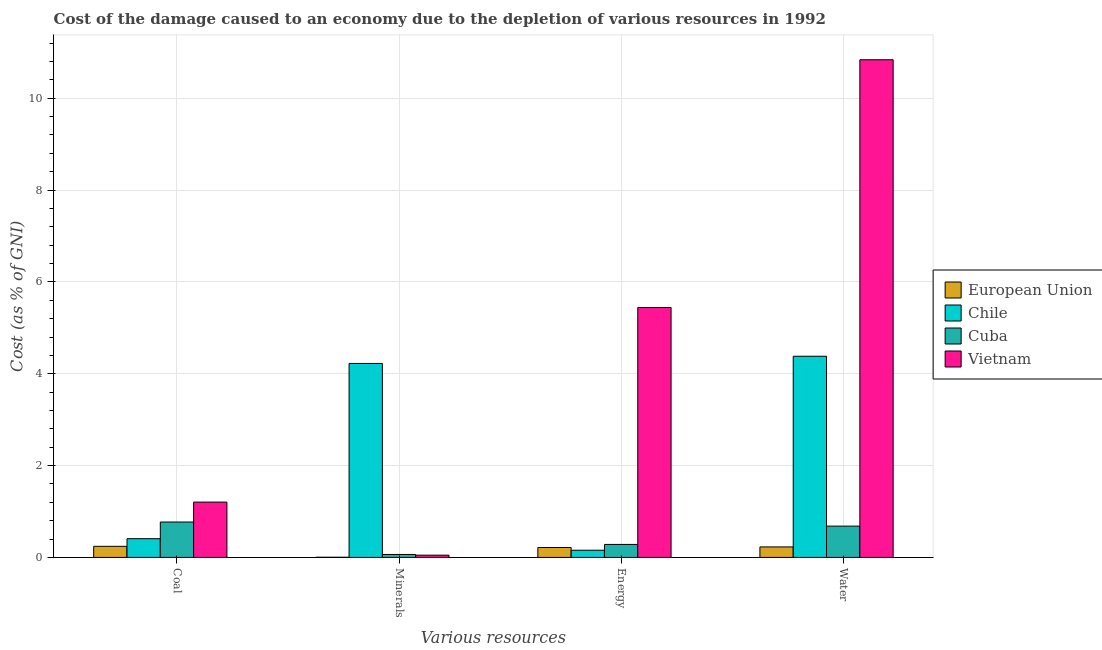How many groups of bars are there?
Provide a short and direct response. 4. Are the number of bars per tick equal to the number of legend labels?
Your answer should be very brief. Yes. Are the number of bars on each tick of the X-axis equal?
Keep it short and to the point. Yes. What is the label of the 1st group of bars from the left?
Give a very brief answer. Coal. What is the cost of damage due to depletion of water in Cuba?
Your answer should be very brief. 0.68. Across all countries, what is the maximum cost of damage due to depletion of coal?
Keep it short and to the point. 1.2. Across all countries, what is the minimum cost of damage due to depletion of minerals?
Your response must be concise. 0. In which country was the cost of damage due to depletion of energy maximum?
Provide a succinct answer. Vietnam. In which country was the cost of damage due to depletion of minerals minimum?
Provide a succinct answer. European Union. What is the total cost of damage due to depletion of water in the graph?
Provide a succinct answer. 16.13. What is the difference between the cost of damage due to depletion of minerals in European Union and that in Vietnam?
Offer a terse response. -0.05. What is the difference between the cost of damage due to depletion of energy in Cuba and the cost of damage due to depletion of coal in European Union?
Give a very brief answer. 0.04. What is the average cost of damage due to depletion of minerals per country?
Your answer should be very brief. 1.09. What is the difference between the cost of damage due to depletion of minerals and cost of damage due to depletion of coal in Chile?
Offer a very short reply. 3.82. What is the ratio of the cost of damage due to depletion of coal in Cuba to that in Vietnam?
Keep it short and to the point. 0.64. Is the difference between the cost of damage due to depletion of coal in Vietnam and European Union greater than the difference between the cost of damage due to depletion of energy in Vietnam and European Union?
Provide a succinct answer. No. What is the difference between the highest and the second highest cost of damage due to depletion of energy?
Your answer should be compact. 5.16. What is the difference between the highest and the lowest cost of damage due to depletion of coal?
Your answer should be compact. 0.96. Is the sum of the cost of damage due to depletion of energy in Cuba and European Union greater than the maximum cost of damage due to depletion of coal across all countries?
Your answer should be very brief. No. Is it the case that in every country, the sum of the cost of damage due to depletion of energy and cost of damage due to depletion of coal is greater than the sum of cost of damage due to depletion of minerals and cost of damage due to depletion of water?
Your answer should be very brief. No. What does the 2nd bar from the right in Coal represents?
Provide a succinct answer. Cuba. How many bars are there?
Offer a terse response. 16. Are all the bars in the graph horizontal?
Ensure brevity in your answer.  No. How many countries are there in the graph?
Offer a very short reply. 4. Where does the legend appear in the graph?
Make the answer very short. Center right. What is the title of the graph?
Provide a succinct answer. Cost of the damage caused to an economy due to the depletion of various resources in 1992 . Does "Bulgaria" appear as one of the legend labels in the graph?
Your response must be concise. No. What is the label or title of the X-axis?
Provide a short and direct response. Various resources. What is the label or title of the Y-axis?
Provide a short and direct response. Cost (as % of GNI). What is the Cost (as % of GNI) of European Union in Coal?
Provide a short and direct response. 0.24. What is the Cost (as % of GNI) of Chile in Coal?
Provide a succinct answer. 0.41. What is the Cost (as % of GNI) of Cuba in Coal?
Your response must be concise. 0.77. What is the Cost (as % of GNI) in Vietnam in Coal?
Provide a short and direct response. 1.2. What is the Cost (as % of GNI) in European Union in Minerals?
Provide a short and direct response. 0. What is the Cost (as % of GNI) in Chile in Minerals?
Your response must be concise. 4.22. What is the Cost (as % of GNI) in Cuba in Minerals?
Ensure brevity in your answer.  0.06. What is the Cost (as % of GNI) of Vietnam in Minerals?
Your response must be concise. 0.05. What is the Cost (as % of GNI) of European Union in Energy?
Make the answer very short. 0.22. What is the Cost (as % of GNI) in Chile in Energy?
Your answer should be compact. 0.16. What is the Cost (as % of GNI) in Cuba in Energy?
Give a very brief answer. 0.28. What is the Cost (as % of GNI) of Vietnam in Energy?
Offer a terse response. 5.44. What is the Cost (as % of GNI) of European Union in Water?
Make the answer very short. 0.23. What is the Cost (as % of GNI) of Chile in Water?
Provide a succinct answer. 4.38. What is the Cost (as % of GNI) in Cuba in Water?
Provide a short and direct response. 0.68. What is the Cost (as % of GNI) of Vietnam in Water?
Offer a terse response. 10.84. Across all Various resources, what is the maximum Cost (as % of GNI) in European Union?
Give a very brief answer. 0.24. Across all Various resources, what is the maximum Cost (as % of GNI) of Chile?
Your answer should be compact. 4.38. Across all Various resources, what is the maximum Cost (as % of GNI) in Cuba?
Your response must be concise. 0.77. Across all Various resources, what is the maximum Cost (as % of GNI) of Vietnam?
Give a very brief answer. 10.84. Across all Various resources, what is the minimum Cost (as % of GNI) of European Union?
Ensure brevity in your answer.  0. Across all Various resources, what is the minimum Cost (as % of GNI) of Chile?
Give a very brief answer. 0.16. Across all Various resources, what is the minimum Cost (as % of GNI) in Cuba?
Make the answer very short. 0.06. Across all Various resources, what is the minimum Cost (as % of GNI) of Vietnam?
Make the answer very short. 0.05. What is the total Cost (as % of GNI) of European Union in the graph?
Provide a short and direct response. 0.69. What is the total Cost (as % of GNI) of Chile in the graph?
Your answer should be compact. 9.17. What is the total Cost (as % of GNI) in Cuba in the graph?
Offer a very short reply. 1.8. What is the total Cost (as % of GNI) of Vietnam in the graph?
Your answer should be compact. 17.53. What is the difference between the Cost (as % of GNI) in European Union in Coal and that in Minerals?
Make the answer very short. 0.24. What is the difference between the Cost (as % of GNI) of Chile in Coal and that in Minerals?
Ensure brevity in your answer.  -3.82. What is the difference between the Cost (as % of GNI) in Cuba in Coal and that in Minerals?
Your answer should be very brief. 0.71. What is the difference between the Cost (as % of GNI) of Vietnam in Coal and that in Minerals?
Make the answer very short. 1.16. What is the difference between the Cost (as % of GNI) in European Union in Coal and that in Energy?
Your answer should be very brief. 0.03. What is the difference between the Cost (as % of GNI) in Chile in Coal and that in Energy?
Ensure brevity in your answer.  0.25. What is the difference between the Cost (as % of GNI) in Cuba in Coal and that in Energy?
Ensure brevity in your answer.  0.49. What is the difference between the Cost (as % of GNI) of Vietnam in Coal and that in Energy?
Your answer should be compact. -4.24. What is the difference between the Cost (as % of GNI) in European Union in Coal and that in Water?
Offer a terse response. 0.01. What is the difference between the Cost (as % of GNI) of Chile in Coal and that in Water?
Your answer should be very brief. -3.97. What is the difference between the Cost (as % of GNI) of Cuba in Coal and that in Water?
Offer a very short reply. 0.09. What is the difference between the Cost (as % of GNI) of Vietnam in Coal and that in Water?
Your answer should be very brief. -9.63. What is the difference between the Cost (as % of GNI) of European Union in Minerals and that in Energy?
Ensure brevity in your answer.  -0.21. What is the difference between the Cost (as % of GNI) in Chile in Minerals and that in Energy?
Keep it short and to the point. 4.07. What is the difference between the Cost (as % of GNI) of Cuba in Minerals and that in Energy?
Your response must be concise. -0.22. What is the difference between the Cost (as % of GNI) in Vietnam in Minerals and that in Energy?
Make the answer very short. -5.39. What is the difference between the Cost (as % of GNI) in European Union in Minerals and that in Water?
Your response must be concise. -0.23. What is the difference between the Cost (as % of GNI) in Chile in Minerals and that in Water?
Keep it short and to the point. -0.16. What is the difference between the Cost (as % of GNI) in Cuba in Minerals and that in Water?
Provide a succinct answer. -0.62. What is the difference between the Cost (as % of GNI) in Vietnam in Minerals and that in Water?
Offer a very short reply. -10.79. What is the difference between the Cost (as % of GNI) in European Union in Energy and that in Water?
Give a very brief answer. -0.01. What is the difference between the Cost (as % of GNI) in Chile in Energy and that in Water?
Your answer should be very brief. -4.22. What is the difference between the Cost (as % of GNI) in Cuba in Energy and that in Water?
Your answer should be compact. -0.4. What is the difference between the Cost (as % of GNI) in Vietnam in Energy and that in Water?
Keep it short and to the point. -5.39. What is the difference between the Cost (as % of GNI) in European Union in Coal and the Cost (as % of GNI) in Chile in Minerals?
Make the answer very short. -3.98. What is the difference between the Cost (as % of GNI) of European Union in Coal and the Cost (as % of GNI) of Cuba in Minerals?
Give a very brief answer. 0.18. What is the difference between the Cost (as % of GNI) of European Union in Coal and the Cost (as % of GNI) of Vietnam in Minerals?
Give a very brief answer. 0.19. What is the difference between the Cost (as % of GNI) in Chile in Coal and the Cost (as % of GNI) in Cuba in Minerals?
Your answer should be compact. 0.34. What is the difference between the Cost (as % of GNI) in Chile in Coal and the Cost (as % of GNI) in Vietnam in Minerals?
Keep it short and to the point. 0.36. What is the difference between the Cost (as % of GNI) in Cuba in Coal and the Cost (as % of GNI) in Vietnam in Minerals?
Offer a terse response. 0.72. What is the difference between the Cost (as % of GNI) of European Union in Coal and the Cost (as % of GNI) of Chile in Energy?
Ensure brevity in your answer.  0.09. What is the difference between the Cost (as % of GNI) in European Union in Coal and the Cost (as % of GNI) in Cuba in Energy?
Offer a terse response. -0.04. What is the difference between the Cost (as % of GNI) in European Union in Coal and the Cost (as % of GNI) in Vietnam in Energy?
Make the answer very short. -5.2. What is the difference between the Cost (as % of GNI) of Chile in Coal and the Cost (as % of GNI) of Vietnam in Energy?
Offer a terse response. -5.03. What is the difference between the Cost (as % of GNI) in Cuba in Coal and the Cost (as % of GNI) in Vietnam in Energy?
Ensure brevity in your answer.  -4.67. What is the difference between the Cost (as % of GNI) in European Union in Coal and the Cost (as % of GNI) in Chile in Water?
Your answer should be very brief. -4.14. What is the difference between the Cost (as % of GNI) of European Union in Coal and the Cost (as % of GNI) of Cuba in Water?
Give a very brief answer. -0.44. What is the difference between the Cost (as % of GNI) in European Union in Coal and the Cost (as % of GNI) in Vietnam in Water?
Your answer should be very brief. -10.6. What is the difference between the Cost (as % of GNI) in Chile in Coal and the Cost (as % of GNI) in Cuba in Water?
Give a very brief answer. -0.27. What is the difference between the Cost (as % of GNI) of Chile in Coal and the Cost (as % of GNI) of Vietnam in Water?
Give a very brief answer. -10.43. What is the difference between the Cost (as % of GNI) of Cuba in Coal and the Cost (as % of GNI) of Vietnam in Water?
Offer a very short reply. -10.07. What is the difference between the Cost (as % of GNI) of European Union in Minerals and the Cost (as % of GNI) of Chile in Energy?
Your answer should be very brief. -0.15. What is the difference between the Cost (as % of GNI) in European Union in Minerals and the Cost (as % of GNI) in Cuba in Energy?
Ensure brevity in your answer.  -0.28. What is the difference between the Cost (as % of GNI) in European Union in Minerals and the Cost (as % of GNI) in Vietnam in Energy?
Offer a terse response. -5.44. What is the difference between the Cost (as % of GNI) of Chile in Minerals and the Cost (as % of GNI) of Cuba in Energy?
Provide a succinct answer. 3.94. What is the difference between the Cost (as % of GNI) of Chile in Minerals and the Cost (as % of GNI) of Vietnam in Energy?
Your answer should be compact. -1.22. What is the difference between the Cost (as % of GNI) in Cuba in Minerals and the Cost (as % of GNI) in Vietnam in Energy?
Provide a succinct answer. -5.38. What is the difference between the Cost (as % of GNI) in European Union in Minerals and the Cost (as % of GNI) in Chile in Water?
Make the answer very short. -4.38. What is the difference between the Cost (as % of GNI) of European Union in Minerals and the Cost (as % of GNI) of Cuba in Water?
Your response must be concise. -0.68. What is the difference between the Cost (as % of GNI) of European Union in Minerals and the Cost (as % of GNI) of Vietnam in Water?
Your answer should be very brief. -10.83. What is the difference between the Cost (as % of GNI) in Chile in Minerals and the Cost (as % of GNI) in Cuba in Water?
Offer a terse response. 3.54. What is the difference between the Cost (as % of GNI) in Chile in Minerals and the Cost (as % of GNI) in Vietnam in Water?
Your answer should be compact. -6.61. What is the difference between the Cost (as % of GNI) of Cuba in Minerals and the Cost (as % of GNI) of Vietnam in Water?
Your answer should be very brief. -10.77. What is the difference between the Cost (as % of GNI) in European Union in Energy and the Cost (as % of GNI) in Chile in Water?
Offer a terse response. -4.17. What is the difference between the Cost (as % of GNI) of European Union in Energy and the Cost (as % of GNI) of Cuba in Water?
Ensure brevity in your answer.  -0.47. What is the difference between the Cost (as % of GNI) of European Union in Energy and the Cost (as % of GNI) of Vietnam in Water?
Ensure brevity in your answer.  -10.62. What is the difference between the Cost (as % of GNI) in Chile in Energy and the Cost (as % of GNI) in Cuba in Water?
Offer a terse response. -0.52. What is the difference between the Cost (as % of GNI) of Chile in Energy and the Cost (as % of GNI) of Vietnam in Water?
Your answer should be very brief. -10.68. What is the difference between the Cost (as % of GNI) of Cuba in Energy and the Cost (as % of GNI) of Vietnam in Water?
Offer a very short reply. -10.55. What is the average Cost (as % of GNI) of European Union per Various resources?
Ensure brevity in your answer.  0.17. What is the average Cost (as % of GNI) in Chile per Various resources?
Your answer should be compact. 2.29. What is the average Cost (as % of GNI) in Cuba per Various resources?
Your answer should be very brief. 0.45. What is the average Cost (as % of GNI) of Vietnam per Various resources?
Offer a very short reply. 4.38. What is the difference between the Cost (as % of GNI) of European Union and Cost (as % of GNI) of Chile in Coal?
Offer a terse response. -0.17. What is the difference between the Cost (as % of GNI) of European Union and Cost (as % of GNI) of Cuba in Coal?
Your answer should be compact. -0.53. What is the difference between the Cost (as % of GNI) in European Union and Cost (as % of GNI) in Vietnam in Coal?
Your answer should be compact. -0.96. What is the difference between the Cost (as % of GNI) of Chile and Cost (as % of GNI) of Cuba in Coal?
Provide a short and direct response. -0.36. What is the difference between the Cost (as % of GNI) in Chile and Cost (as % of GNI) in Vietnam in Coal?
Your answer should be compact. -0.8. What is the difference between the Cost (as % of GNI) in Cuba and Cost (as % of GNI) in Vietnam in Coal?
Make the answer very short. -0.43. What is the difference between the Cost (as % of GNI) of European Union and Cost (as % of GNI) of Chile in Minerals?
Give a very brief answer. -4.22. What is the difference between the Cost (as % of GNI) of European Union and Cost (as % of GNI) of Cuba in Minerals?
Offer a very short reply. -0.06. What is the difference between the Cost (as % of GNI) of European Union and Cost (as % of GNI) of Vietnam in Minerals?
Ensure brevity in your answer.  -0.05. What is the difference between the Cost (as % of GNI) in Chile and Cost (as % of GNI) in Cuba in Minerals?
Keep it short and to the point. 4.16. What is the difference between the Cost (as % of GNI) in Chile and Cost (as % of GNI) in Vietnam in Minerals?
Keep it short and to the point. 4.18. What is the difference between the Cost (as % of GNI) of Cuba and Cost (as % of GNI) of Vietnam in Minerals?
Keep it short and to the point. 0.02. What is the difference between the Cost (as % of GNI) of European Union and Cost (as % of GNI) of Chile in Energy?
Offer a very short reply. 0.06. What is the difference between the Cost (as % of GNI) of European Union and Cost (as % of GNI) of Cuba in Energy?
Your answer should be compact. -0.07. What is the difference between the Cost (as % of GNI) in European Union and Cost (as % of GNI) in Vietnam in Energy?
Offer a terse response. -5.23. What is the difference between the Cost (as % of GNI) of Chile and Cost (as % of GNI) of Cuba in Energy?
Give a very brief answer. -0.13. What is the difference between the Cost (as % of GNI) of Chile and Cost (as % of GNI) of Vietnam in Energy?
Keep it short and to the point. -5.29. What is the difference between the Cost (as % of GNI) of Cuba and Cost (as % of GNI) of Vietnam in Energy?
Provide a succinct answer. -5.16. What is the difference between the Cost (as % of GNI) in European Union and Cost (as % of GNI) in Chile in Water?
Keep it short and to the point. -4.15. What is the difference between the Cost (as % of GNI) of European Union and Cost (as % of GNI) of Cuba in Water?
Your answer should be very brief. -0.45. What is the difference between the Cost (as % of GNI) in European Union and Cost (as % of GNI) in Vietnam in Water?
Provide a short and direct response. -10.61. What is the difference between the Cost (as % of GNI) in Chile and Cost (as % of GNI) in Cuba in Water?
Make the answer very short. 3.7. What is the difference between the Cost (as % of GNI) of Chile and Cost (as % of GNI) of Vietnam in Water?
Provide a succinct answer. -6.46. What is the difference between the Cost (as % of GNI) of Cuba and Cost (as % of GNI) of Vietnam in Water?
Make the answer very short. -10.16. What is the ratio of the Cost (as % of GNI) in European Union in Coal to that in Minerals?
Offer a terse response. 67.03. What is the ratio of the Cost (as % of GNI) in Chile in Coal to that in Minerals?
Ensure brevity in your answer.  0.1. What is the ratio of the Cost (as % of GNI) of Cuba in Coal to that in Minerals?
Keep it short and to the point. 11.96. What is the ratio of the Cost (as % of GNI) in Vietnam in Coal to that in Minerals?
Keep it short and to the point. 24.48. What is the ratio of the Cost (as % of GNI) in European Union in Coal to that in Energy?
Offer a terse response. 1.12. What is the ratio of the Cost (as % of GNI) in Chile in Coal to that in Energy?
Keep it short and to the point. 2.6. What is the ratio of the Cost (as % of GNI) of Cuba in Coal to that in Energy?
Make the answer very short. 2.72. What is the ratio of the Cost (as % of GNI) of Vietnam in Coal to that in Energy?
Make the answer very short. 0.22. What is the ratio of the Cost (as % of GNI) in European Union in Coal to that in Water?
Keep it short and to the point. 1.06. What is the ratio of the Cost (as % of GNI) in Chile in Coal to that in Water?
Your answer should be compact. 0.09. What is the ratio of the Cost (as % of GNI) in Cuba in Coal to that in Water?
Offer a very short reply. 1.13. What is the ratio of the Cost (as % of GNI) in Vietnam in Coal to that in Water?
Provide a short and direct response. 0.11. What is the ratio of the Cost (as % of GNI) of European Union in Minerals to that in Energy?
Provide a succinct answer. 0.02. What is the ratio of the Cost (as % of GNI) in Chile in Minerals to that in Energy?
Provide a short and direct response. 26.95. What is the ratio of the Cost (as % of GNI) of Cuba in Minerals to that in Energy?
Provide a short and direct response. 0.23. What is the ratio of the Cost (as % of GNI) of Vietnam in Minerals to that in Energy?
Offer a very short reply. 0.01. What is the ratio of the Cost (as % of GNI) of European Union in Minerals to that in Water?
Make the answer very short. 0.02. What is the ratio of the Cost (as % of GNI) in Chile in Minerals to that in Water?
Your response must be concise. 0.96. What is the ratio of the Cost (as % of GNI) in Cuba in Minerals to that in Water?
Your answer should be very brief. 0.09. What is the ratio of the Cost (as % of GNI) of Vietnam in Minerals to that in Water?
Your answer should be very brief. 0. What is the ratio of the Cost (as % of GNI) in Chile in Energy to that in Water?
Your answer should be compact. 0.04. What is the ratio of the Cost (as % of GNI) in Cuba in Energy to that in Water?
Provide a succinct answer. 0.42. What is the ratio of the Cost (as % of GNI) in Vietnam in Energy to that in Water?
Ensure brevity in your answer.  0.5. What is the difference between the highest and the second highest Cost (as % of GNI) of European Union?
Your answer should be compact. 0.01. What is the difference between the highest and the second highest Cost (as % of GNI) in Chile?
Offer a very short reply. 0.16. What is the difference between the highest and the second highest Cost (as % of GNI) of Cuba?
Give a very brief answer. 0.09. What is the difference between the highest and the second highest Cost (as % of GNI) of Vietnam?
Keep it short and to the point. 5.39. What is the difference between the highest and the lowest Cost (as % of GNI) of European Union?
Provide a succinct answer. 0.24. What is the difference between the highest and the lowest Cost (as % of GNI) in Chile?
Offer a very short reply. 4.22. What is the difference between the highest and the lowest Cost (as % of GNI) in Cuba?
Provide a short and direct response. 0.71. What is the difference between the highest and the lowest Cost (as % of GNI) of Vietnam?
Your response must be concise. 10.79. 